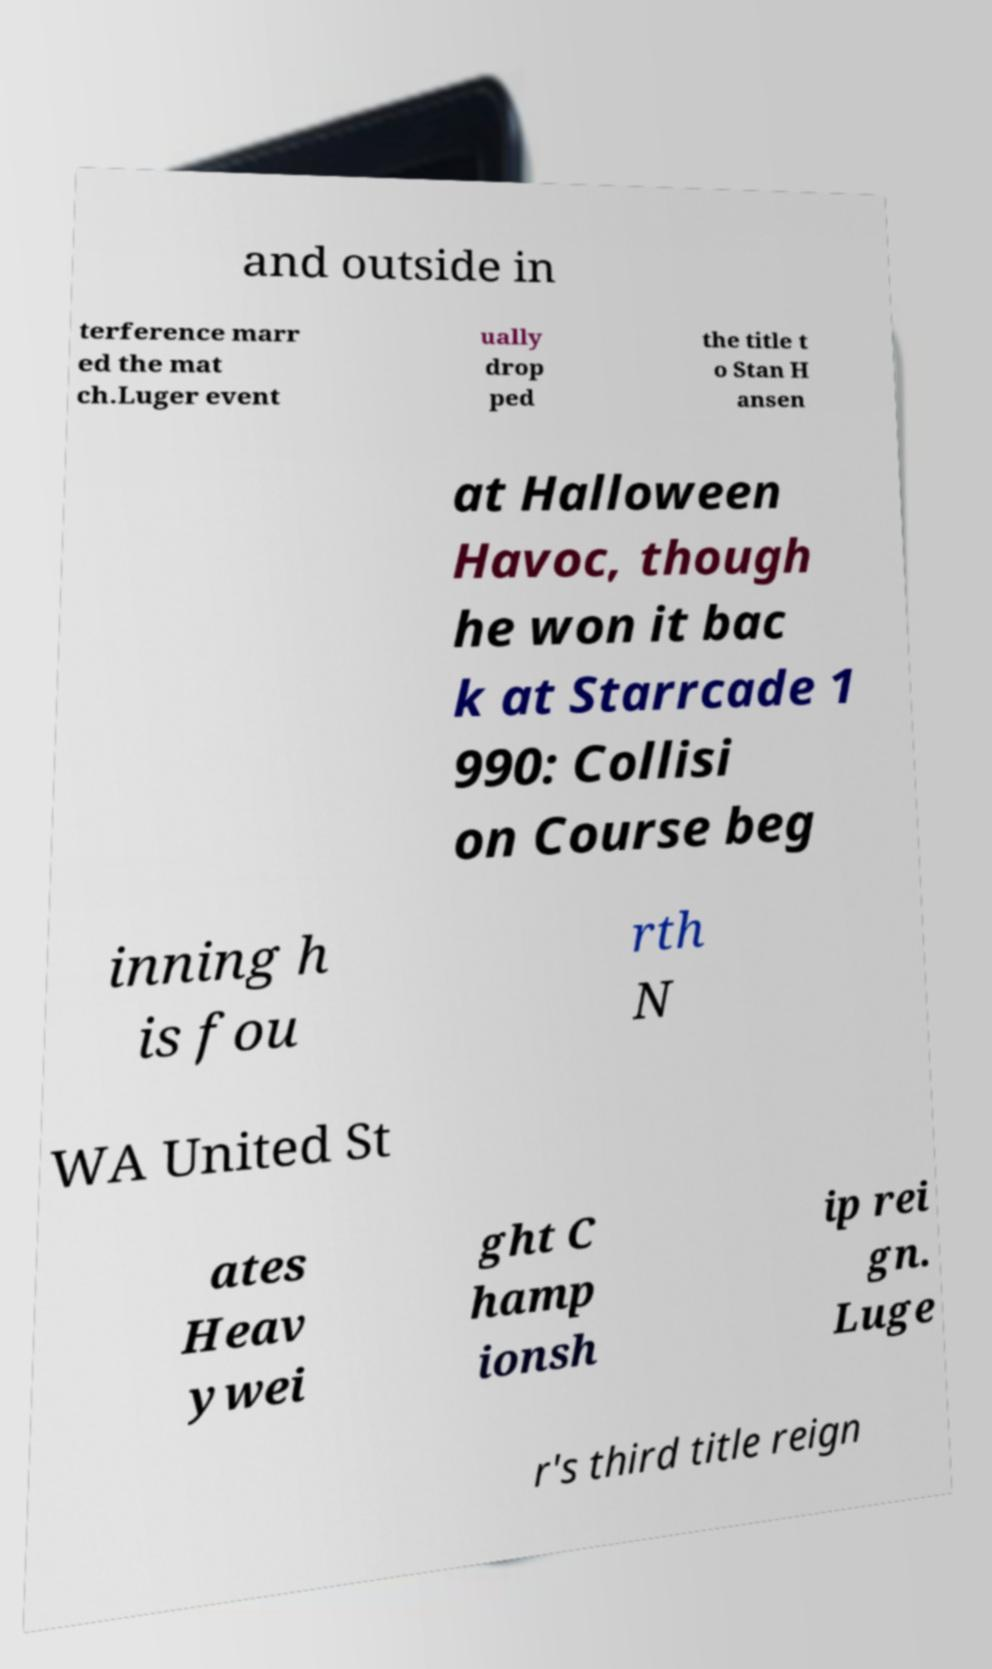What messages or text are displayed in this image? I need them in a readable, typed format. and outside in terference marr ed the mat ch.Luger event ually drop ped the title t o Stan H ansen at Halloween Havoc, though he won it bac k at Starrcade 1 990: Collisi on Course beg inning h is fou rth N WA United St ates Heav ywei ght C hamp ionsh ip rei gn. Luge r's third title reign 